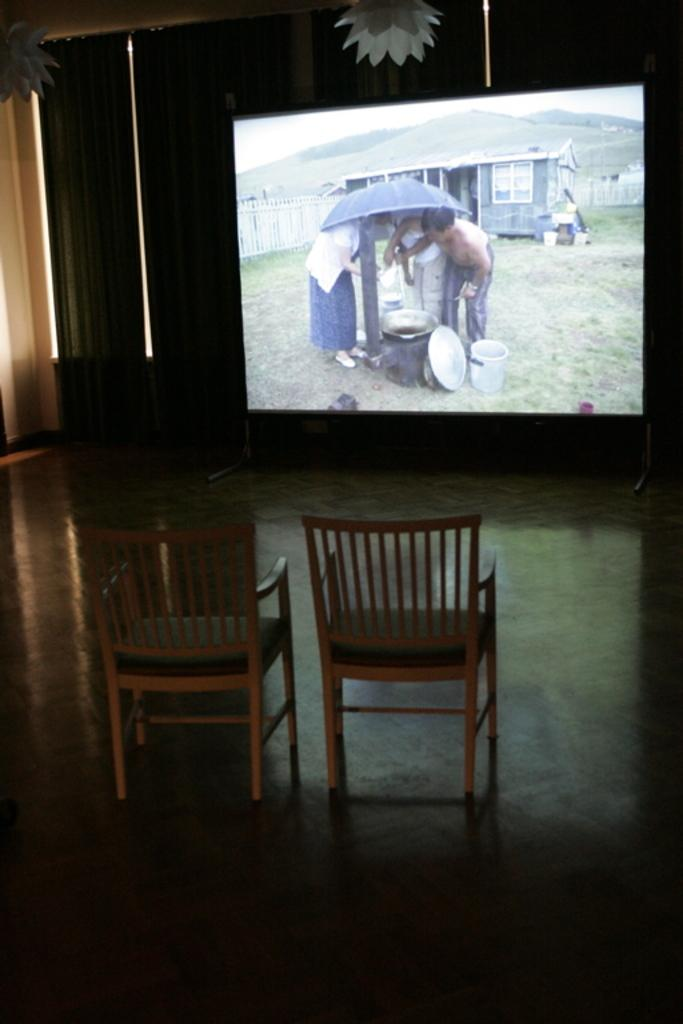How many chairs are visible in the image? There are two chairs in the image. Where are the chairs positioned in relation to the screen? The chairs are in front of the screen. What is being displayed on the screen? A video clip is being played on the screen. How many balls are visible on the chairs in the image? There are no balls visible on the chairs in the image. What type of ornament is hanging from the screen in the image? There is no ornament hanging from the screen in the image. 